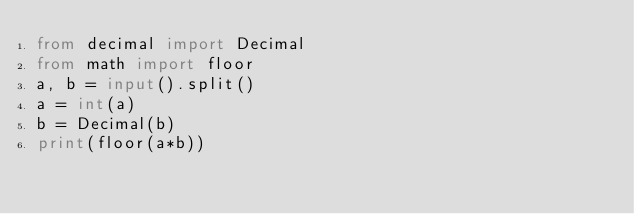<code> <loc_0><loc_0><loc_500><loc_500><_Python_>from decimal import Decimal
from math import floor
a, b = input().split()
a = int(a)
b = Decimal(b)
print(floor(a*b))
</code> 